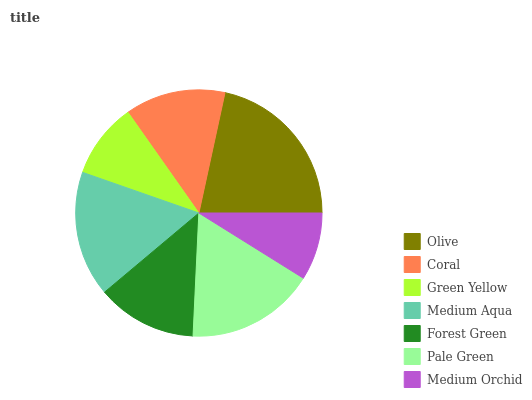Is Medium Orchid the minimum?
Answer yes or no. Yes. Is Olive the maximum?
Answer yes or no. Yes. Is Coral the minimum?
Answer yes or no. No. Is Coral the maximum?
Answer yes or no. No. Is Olive greater than Coral?
Answer yes or no. Yes. Is Coral less than Olive?
Answer yes or no. Yes. Is Coral greater than Olive?
Answer yes or no. No. Is Olive less than Coral?
Answer yes or no. No. Is Coral the high median?
Answer yes or no. Yes. Is Coral the low median?
Answer yes or no. Yes. Is Forest Green the high median?
Answer yes or no. No. Is Medium Orchid the low median?
Answer yes or no. No. 